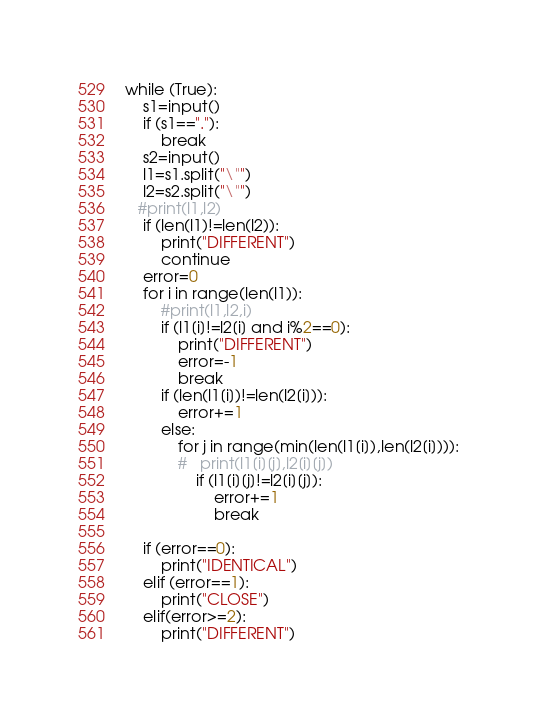<code> <loc_0><loc_0><loc_500><loc_500><_Python_>while (True):
    s1=input()
    if (s1=="."):
        break
    s2=input()
    l1=s1.split("\"")
    l2=s2.split("\"")
   #print(l1,l2)
    if (len(l1)!=len(l2)):
        print("DIFFERENT")
        continue
    error=0
    for i in range(len(l1)):
        #print(l1,l2,i)
        if (l1[i]!=l2[i] and i%2==0):
            print("DIFFERENT")
            error=-1
            break
        if (len(l1[i])!=len(l2[i])):
            error+=1
        else:
            for j in range(min(len(l1[i]),len(l2[i]))):
            #   print(l1[i][j],l2[i][j])
                if (l1[i][j]!=l2[i][j]):
                    error+=1
                    break

    if (error==0):
        print("IDENTICAL")
    elif (error==1):
        print("CLOSE")
    elif(error>=2):
        print("DIFFERENT")
</code> 